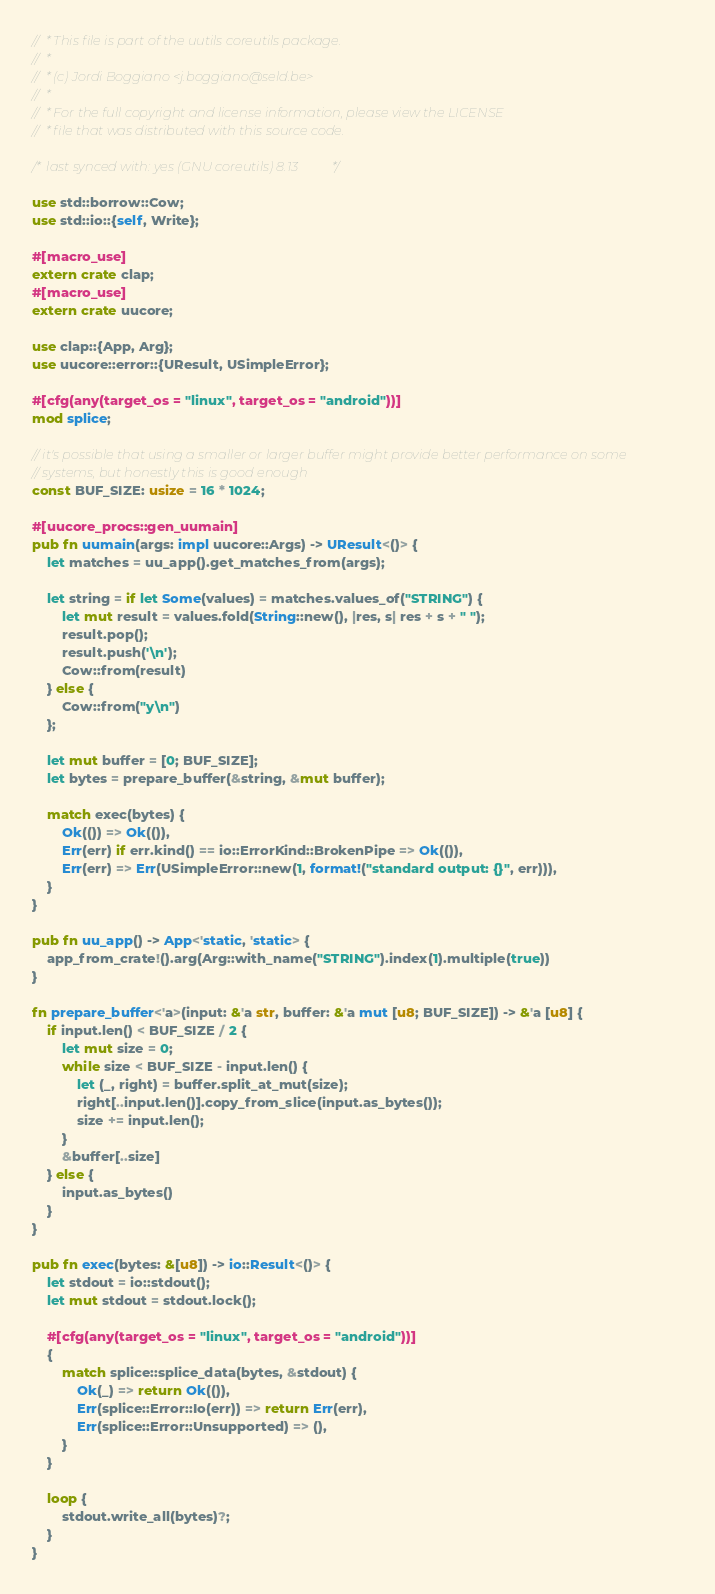<code> <loc_0><loc_0><loc_500><loc_500><_Rust_>//  * This file is part of the uutils coreutils package.
//  *
//  * (c) Jordi Boggiano <j.boggiano@seld.be>
//  *
//  * For the full copyright and license information, please view the LICENSE
//  * file that was distributed with this source code.

/* last synced with: yes (GNU coreutils) 8.13 */

use std::borrow::Cow;
use std::io::{self, Write};

#[macro_use]
extern crate clap;
#[macro_use]
extern crate uucore;

use clap::{App, Arg};
use uucore::error::{UResult, USimpleError};

#[cfg(any(target_os = "linux", target_os = "android"))]
mod splice;

// it's possible that using a smaller or larger buffer might provide better performance on some
// systems, but honestly this is good enough
const BUF_SIZE: usize = 16 * 1024;

#[uucore_procs::gen_uumain]
pub fn uumain(args: impl uucore::Args) -> UResult<()> {
    let matches = uu_app().get_matches_from(args);

    let string = if let Some(values) = matches.values_of("STRING") {
        let mut result = values.fold(String::new(), |res, s| res + s + " ");
        result.pop();
        result.push('\n');
        Cow::from(result)
    } else {
        Cow::from("y\n")
    };

    let mut buffer = [0; BUF_SIZE];
    let bytes = prepare_buffer(&string, &mut buffer);

    match exec(bytes) {
        Ok(()) => Ok(()),
        Err(err) if err.kind() == io::ErrorKind::BrokenPipe => Ok(()),
        Err(err) => Err(USimpleError::new(1, format!("standard output: {}", err))),
    }
}

pub fn uu_app() -> App<'static, 'static> {
    app_from_crate!().arg(Arg::with_name("STRING").index(1).multiple(true))
}

fn prepare_buffer<'a>(input: &'a str, buffer: &'a mut [u8; BUF_SIZE]) -> &'a [u8] {
    if input.len() < BUF_SIZE / 2 {
        let mut size = 0;
        while size < BUF_SIZE - input.len() {
            let (_, right) = buffer.split_at_mut(size);
            right[..input.len()].copy_from_slice(input.as_bytes());
            size += input.len();
        }
        &buffer[..size]
    } else {
        input.as_bytes()
    }
}

pub fn exec(bytes: &[u8]) -> io::Result<()> {
    let stdout = io::stdout();
    let mut stdout = stdout.lock();

    #[cfg(any(target_os = "linux", target_os = "android"))]
    {
        match splice::splice_data(bytes, &stdout) {
            Ok(_) => return Ok(()),
            Err(splice::Error::Io(err)) => return Err(err),
            Err(splice::Error::Unsupported) => (),
        }
    }

    loop {
        stdout.write_all(bytes)?;
    }
}
</code> 